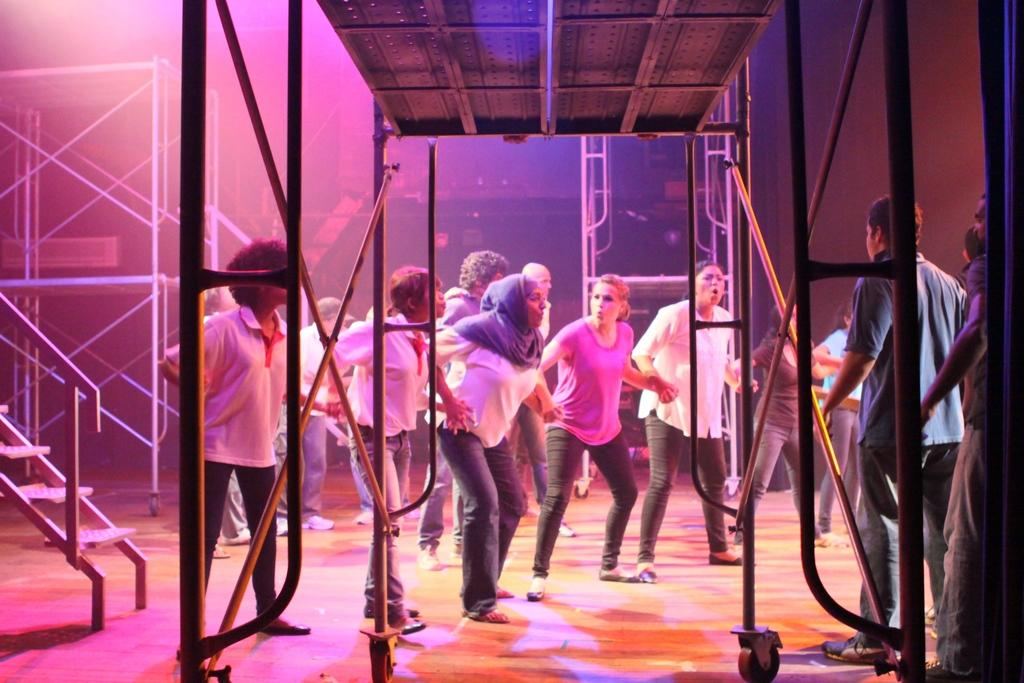What objects can be seen in the image? There are rods and steps in the image. Are there any people present in the image? Yes, there are people in the image. Can you describe the clothing of one of the individuals? A woman is wearing a scarf. What month is it in the image? The month is not mentioned or depicted in the image. Can you describe the loaf of bread being held by the person in the image? There is no loaf of bread present in the image. 